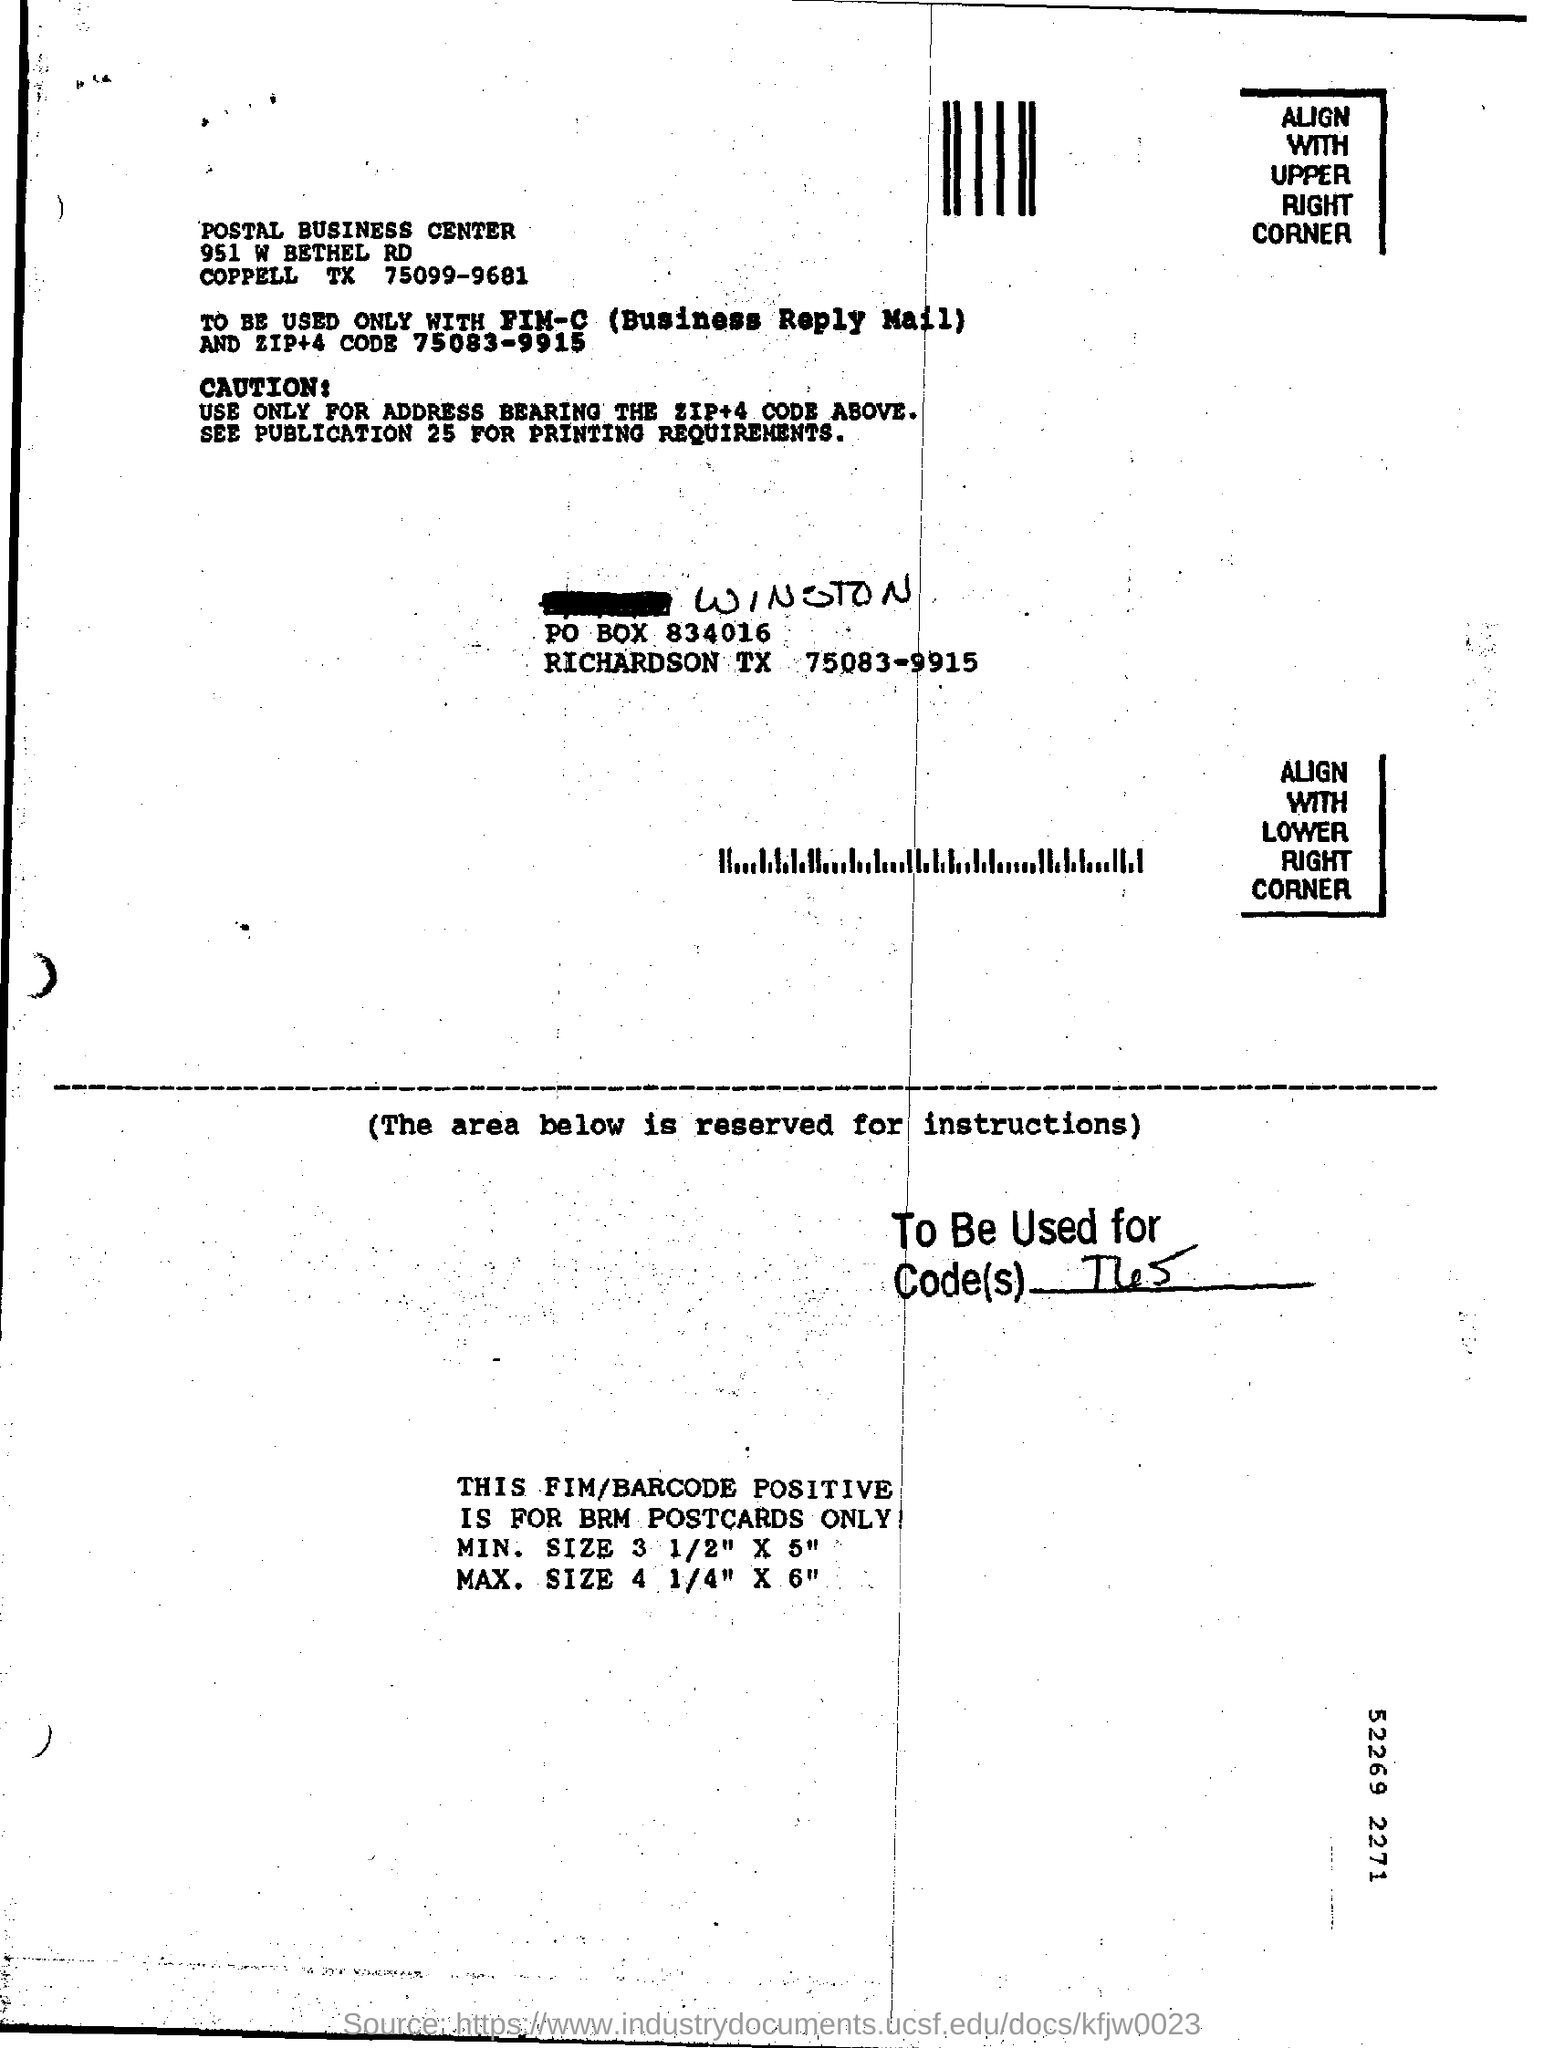Draw attention to some important aspects in this diagram. The name of the center mentioned in the text is "Postal Business Center. 